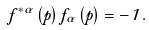<formula> <loc_0><loc_0><loc_500><loc_500>f ^ { * \alpha } \left ( p \right ) f _ { \alpha } \left ( p \right ) = - 1 \, .</formula> 